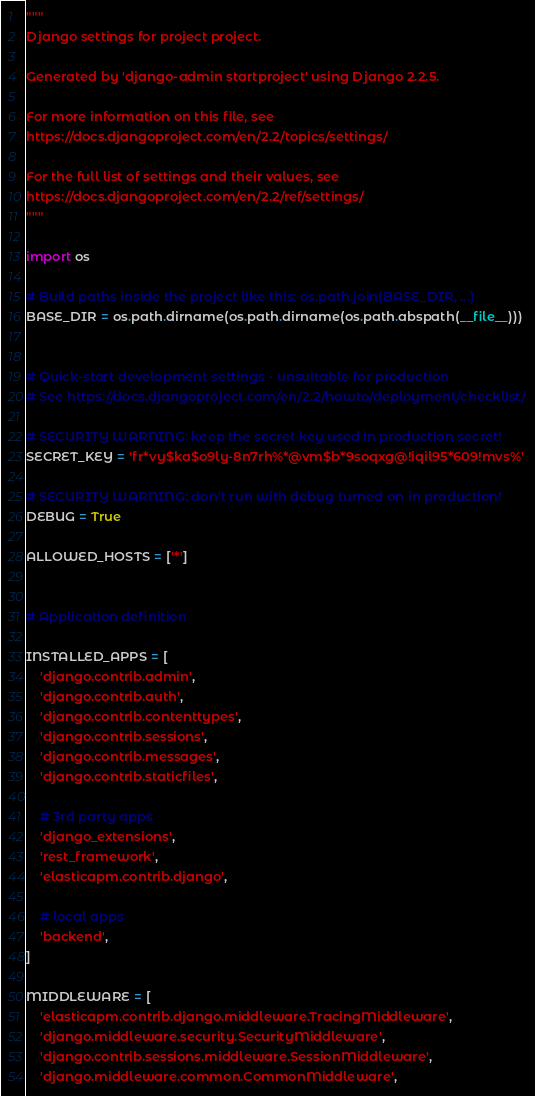Convert code to text. <code><loc_0><loc_0><loc_500><loc_500><_Python_>"""
Django settings for project project.

Generated by 'django-admin startproject' using Django 2.2.5.

For more information on this file, see
https://docs.djangoproject.com/en/2.2/topics/settings/

For the full list of settings and their values, see
https://docs.djangoproject.com/en/2.2/ref/settings/
"""

import os

# Build paths inside the project like this: os.path.join(BASE_DIR, ...)
BASE_DIR = os.path.dirname(os.path.dirname(os.path.abspath(__file__)))


# Quick-start development settings - unsuitable for production
# See https://docs.djangoproject.com/en/2.2/howto/deployment/checklist/

# SECURITY WARNING: keep the secret key used in production secret!
SECRET_KEY = 'fr*vy$ka$o9ly-8n7rh%*@vm$b*9soqxg@!iqil95*609!mvs%'

# SECURITY WARNING: don't run with debug turned on in production!
DEBUG = True

ALLOWED_HOSTS = ['*']


# Application definition

INSTALLED_APPS = [
    'django.contrib.admin',
    'django.contrib.auth',
    'django.contrib.contenttypes',
    'django.contrib.sessions',
    'django.contrib.messages',
    'django.contrib.staticfiles',

    # 3rd party apps
    'django_extensions',
    'rest_framework',
    'elasticapm.contrib.django',

    # local apps
    'backend',
]

MIDDLEWARE = [
    'elasticapm.contrib.django.middleware.TracingMiddleware',
    'django.middleware.security.SecurityMiddleware',
    'django.contrib.sessions.middleware.SessionMiddleware',
    'django.middleware.common.CommonMiddleware',</code> 